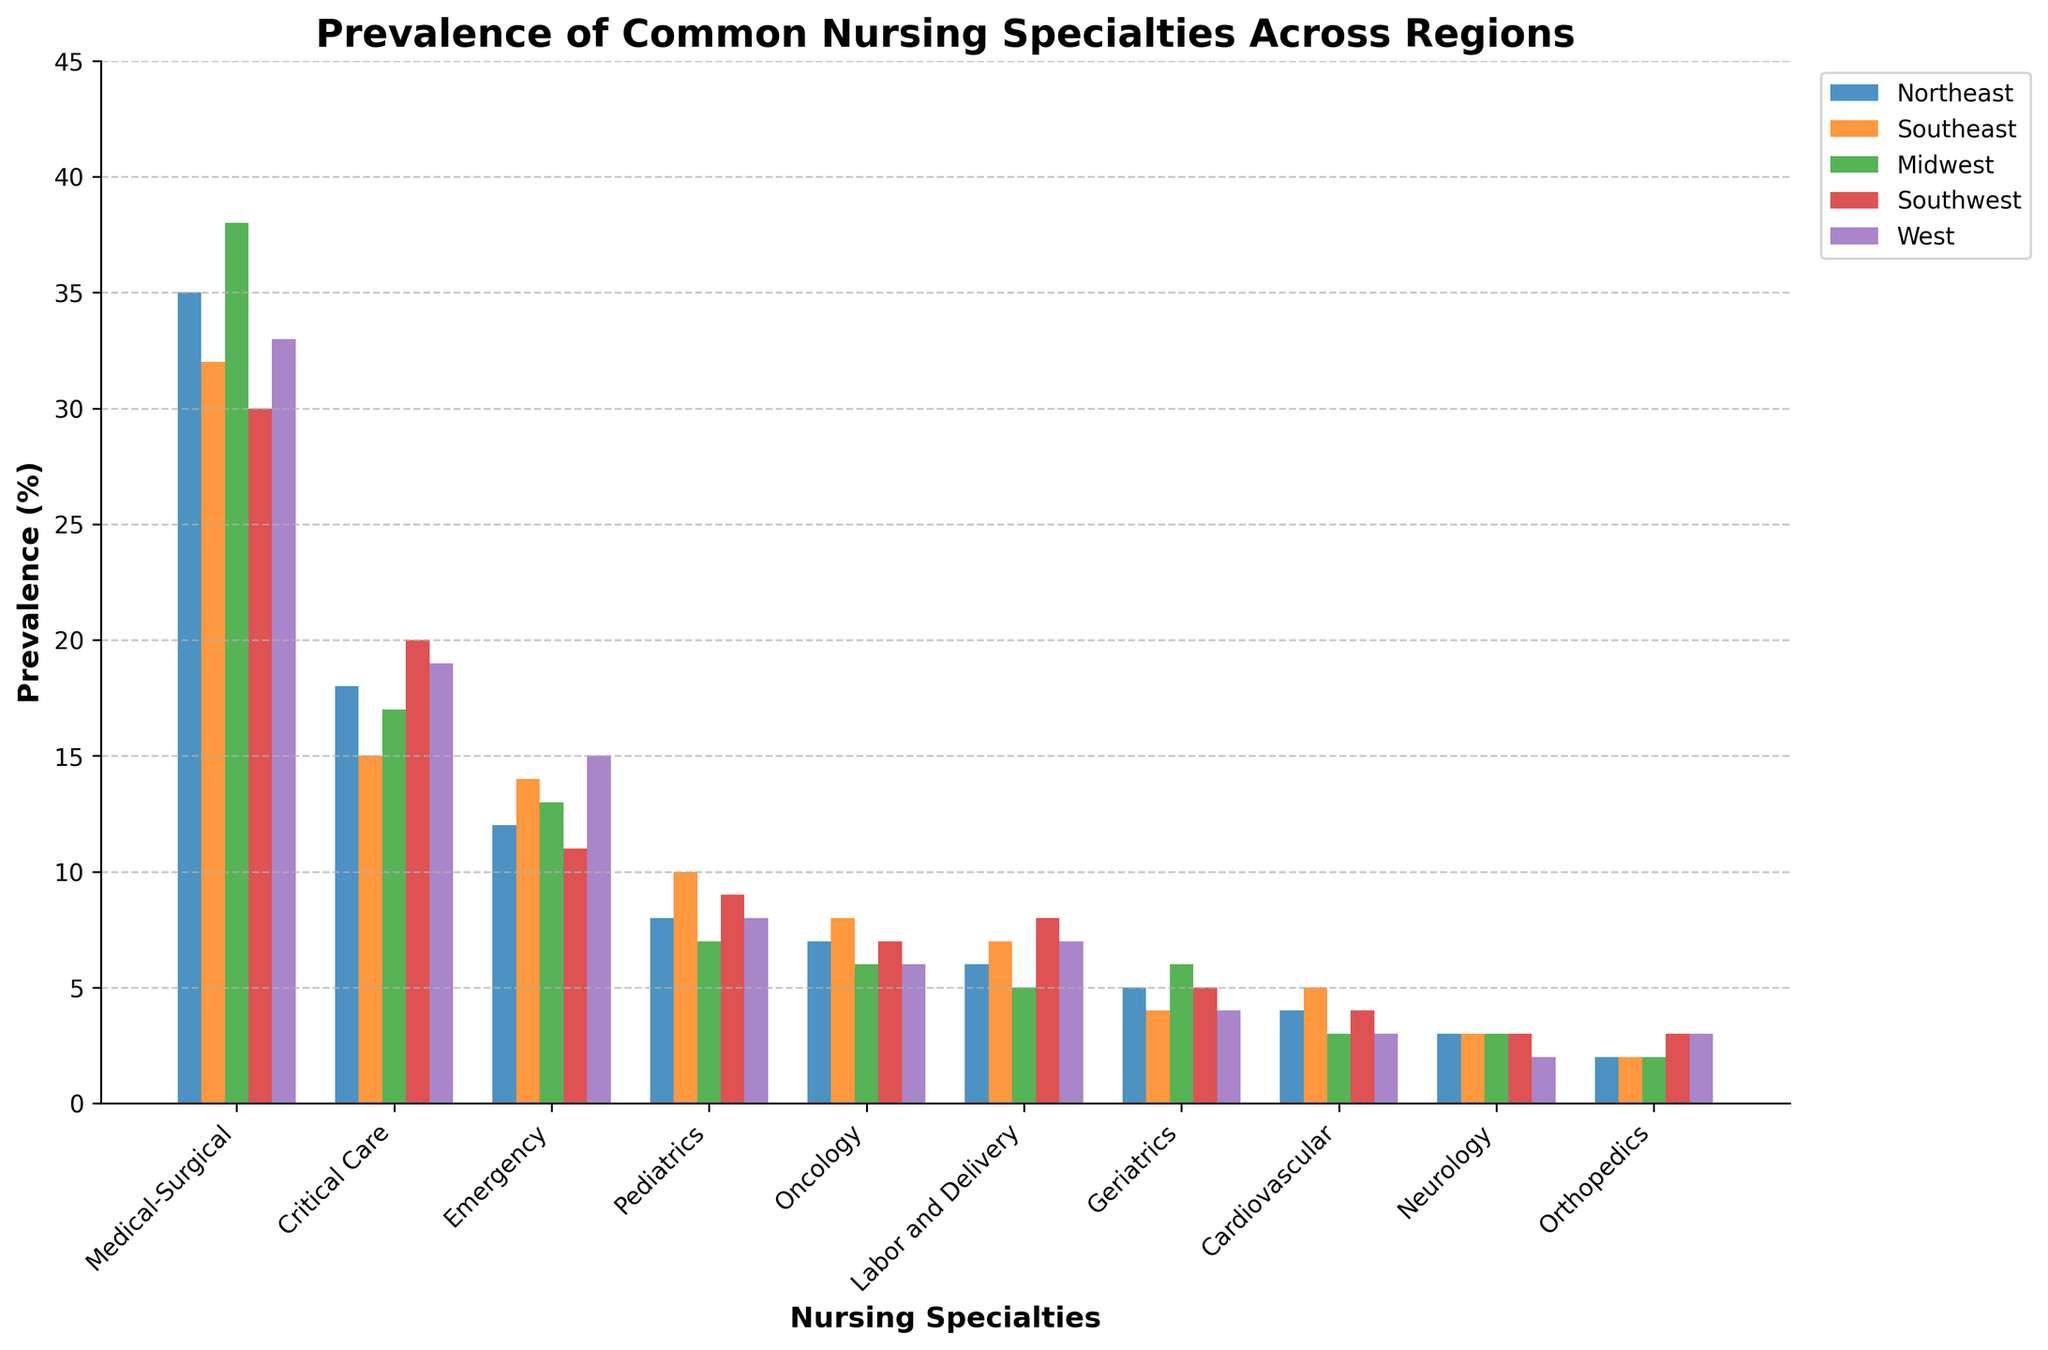What specialty has the highest prevalence in the Midwest? By looking at the height of the bars in the Midwest region, the tallest bar corresponds to the Medical-Surgical specialty.
Answer: Medical-Surgical Which region has the lowest prevalence for Oncology? By comparing the heights of the Oncology bars across all regions, the West region has the shortest bar.
Answer: West Is the prevalence of Pediatrics higher in the Southeast or the Northeast? The bar for Pediatrics in the Southeast is taller than the one in the Northeast, indicating a higher prevalence in the Southeast.
Answer: Southeast What is the total prevalence of Labor and Delivery, Geriatrics, and Neurology in the Southwest? Labor and Delivery in the Southwest is 8, Geriatrics is 5, and Neurology is 3. Summing these values gives 8 + 5 + 3 = 16.
Answer: 16 Which specialties have the same prevalence in the West? Both Neurology and Cardiovascular have the same height in the West, indicating the same prevalence.
Answer: Neurology and Cardiovascular Which region has the most even distribution of prevalences across all specialties? A region with bars of relatively similar heights across all specialties would indicate an even distribution. The West appears to have the most even distribution.
Answer: West What is the difference in prevalence between Critical Care in the Northeast and the Southwest? The prevalence of Critical Care in the Northeast is 18, and in the Southwest, it is 20. The difference is 20 - 18 = 2.
Answer: 2 How does the height of the Emergency bar compare between the West and the Southwest? The Emergency bar in the West is slightly taller than the one in the Southwest, indicating a higher prevalence in the West.
Answer: West Which specialty has the lowest prevalence in both the Southeast and the Midwest? By comparing the bars in the Southeast and Midwest, Orthopedics has the lowest prevalence in both regions.
Answer: Orthopedics What is the average prevalence of Critical Care across all regions? Summing the prevalences of Critical Care (18 + 15 + 17 + 20 + 19) gives 89, and the average is 89 / 5 = 17.8.
Answer: 17.8 